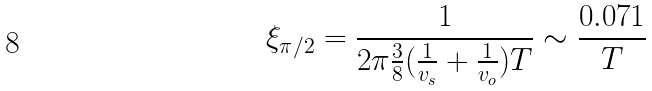Convert formula to latex. <formula><loc_0><loc_0><loc_500><loc_500>\xi _ { \pi / 2 } = \frac { 1 } { 2 \pi \frac { 3 } { 8 } ( \frac { 1 } { v _ { s } } + \frac { 1 } { v _ { o } } ) T } \sim \frac { 0 . 0 7 1 } { T }</formula> 